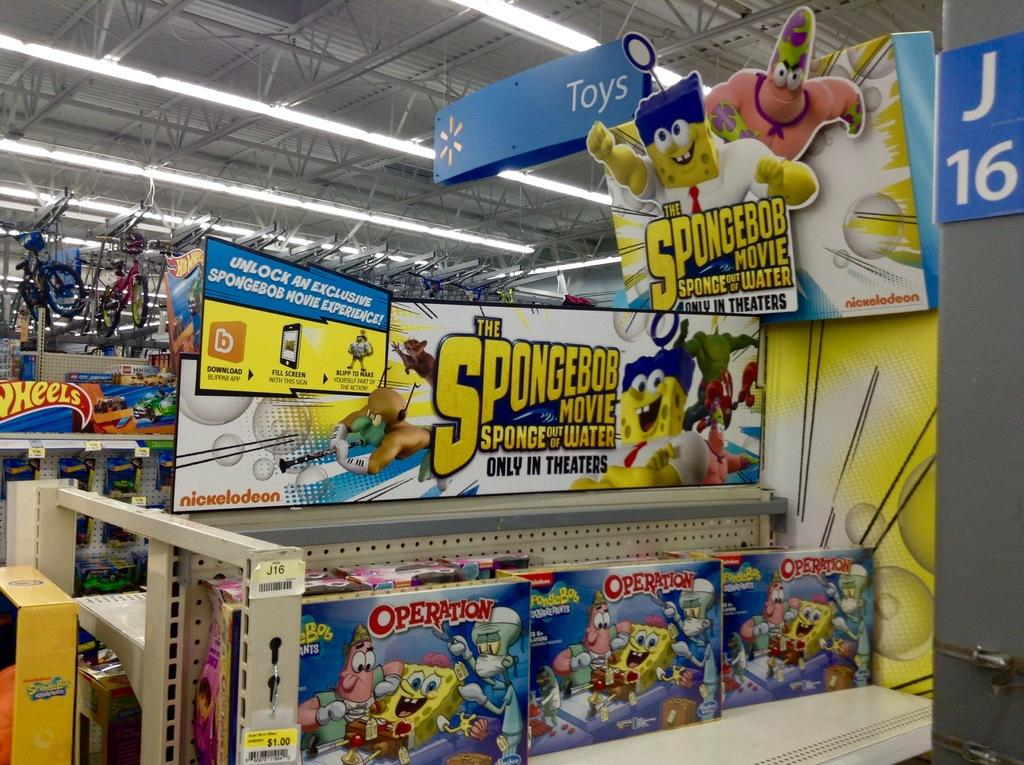<image>
Offer a succinct explanation of the picture presented. A shelf at Walmart with Spongebob Movie toys 